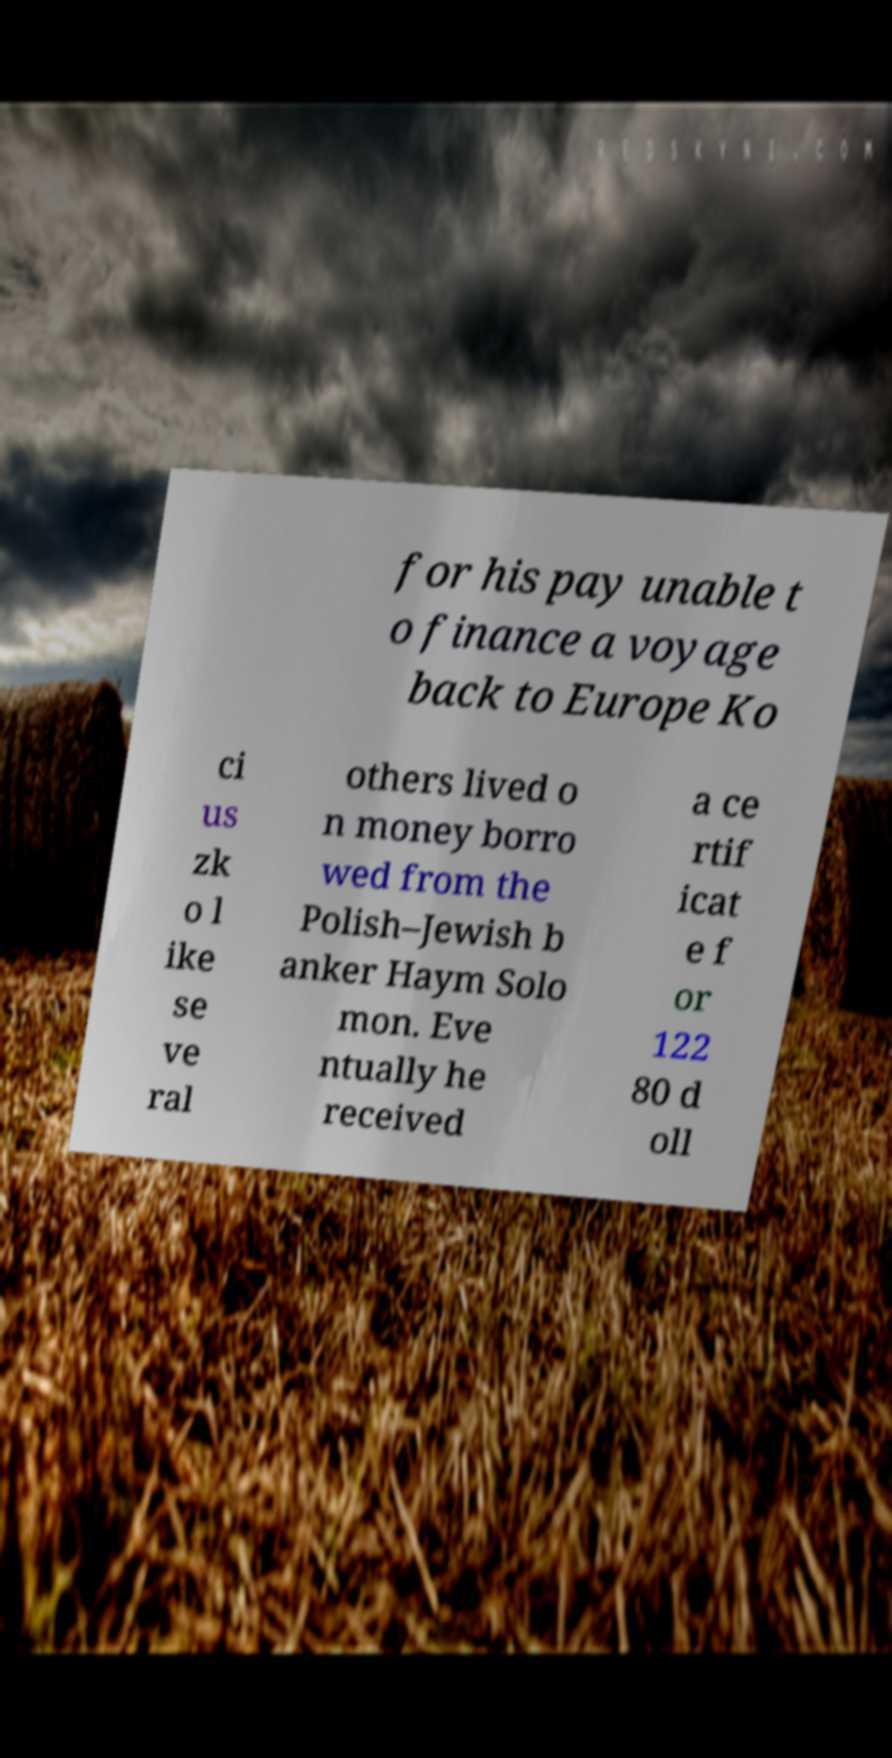For documentation purposes, I need the text within this image transcribed. Could you provide that? for his pay unable t o finance a voyage back to Europe Ko ci us zk o l ike se ve ral others lived o n money borro wed from the Polish–Jewish b anker Haym Solo mon. Eve ntually he received a ce rtif icat e f or 122 80 d oll 